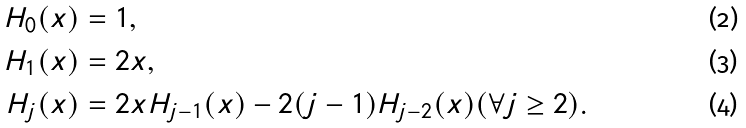<formula> <loc_0><loc_0><loc_500><loc_500>H _ { 0 } ( x ) & = 1 , \\ H _ { 1 } ( x ) & = 2 x , \\ H _ { j } ( x ) & = 2 x H _ { j - 1 } ( x ) - 2 ( j - 1 ) H _ { j - 2 } ( x ) ( \forall j \geq 2 ) .</formula> 